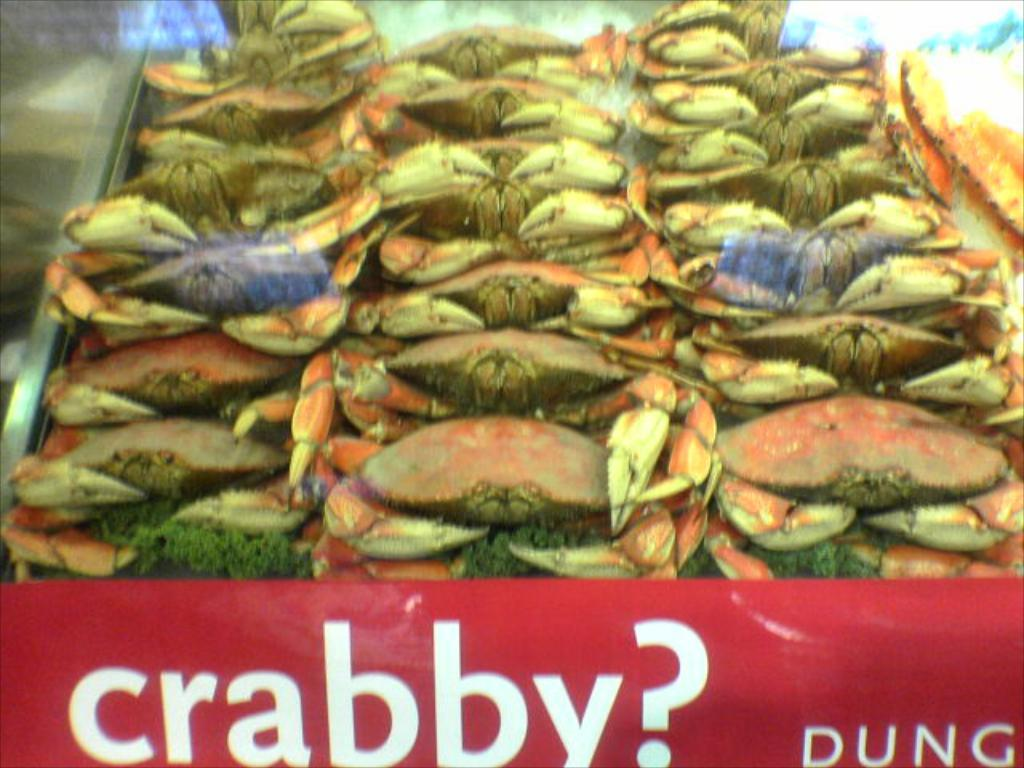What can be found in the image besides the crabs? There is some text in the image. Where are the crabs located in the image? The crabs are in the middle of the image. What type of advice can be seen in the image? There is no advice present in the image; it features text and crabs. Is there a beggar visible in the image? There is no beggar present in the image. 